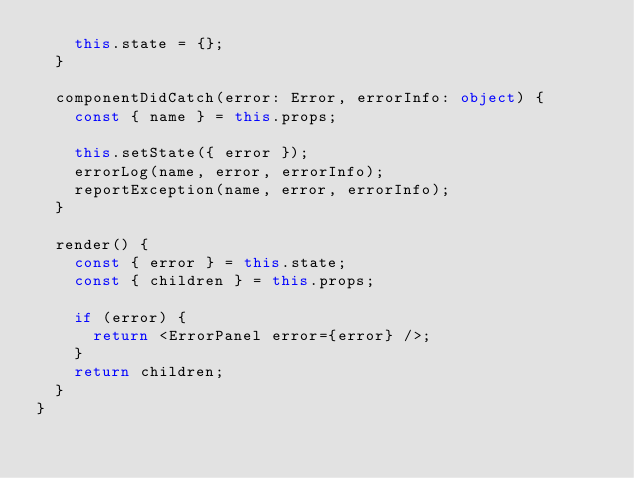Convert code to text. <code><loc_0><loc_0><loc_500><loc_500><_TypeScript_>    this.state = {};
  }

  componentDidCatch(error: Error, errorInfo: object) {
    const { name } = this.props;

    this.setState({ error });
    errorLog(name, error, errorInfo);
    reportException(name, error, errorInfo);
  }

  render() {
    const { error } = this.state;
    const { children } = this.props;

    if (error) {
      return <ErrorPanel error={error} />;
    }
    return children;
  }
}
</code> 